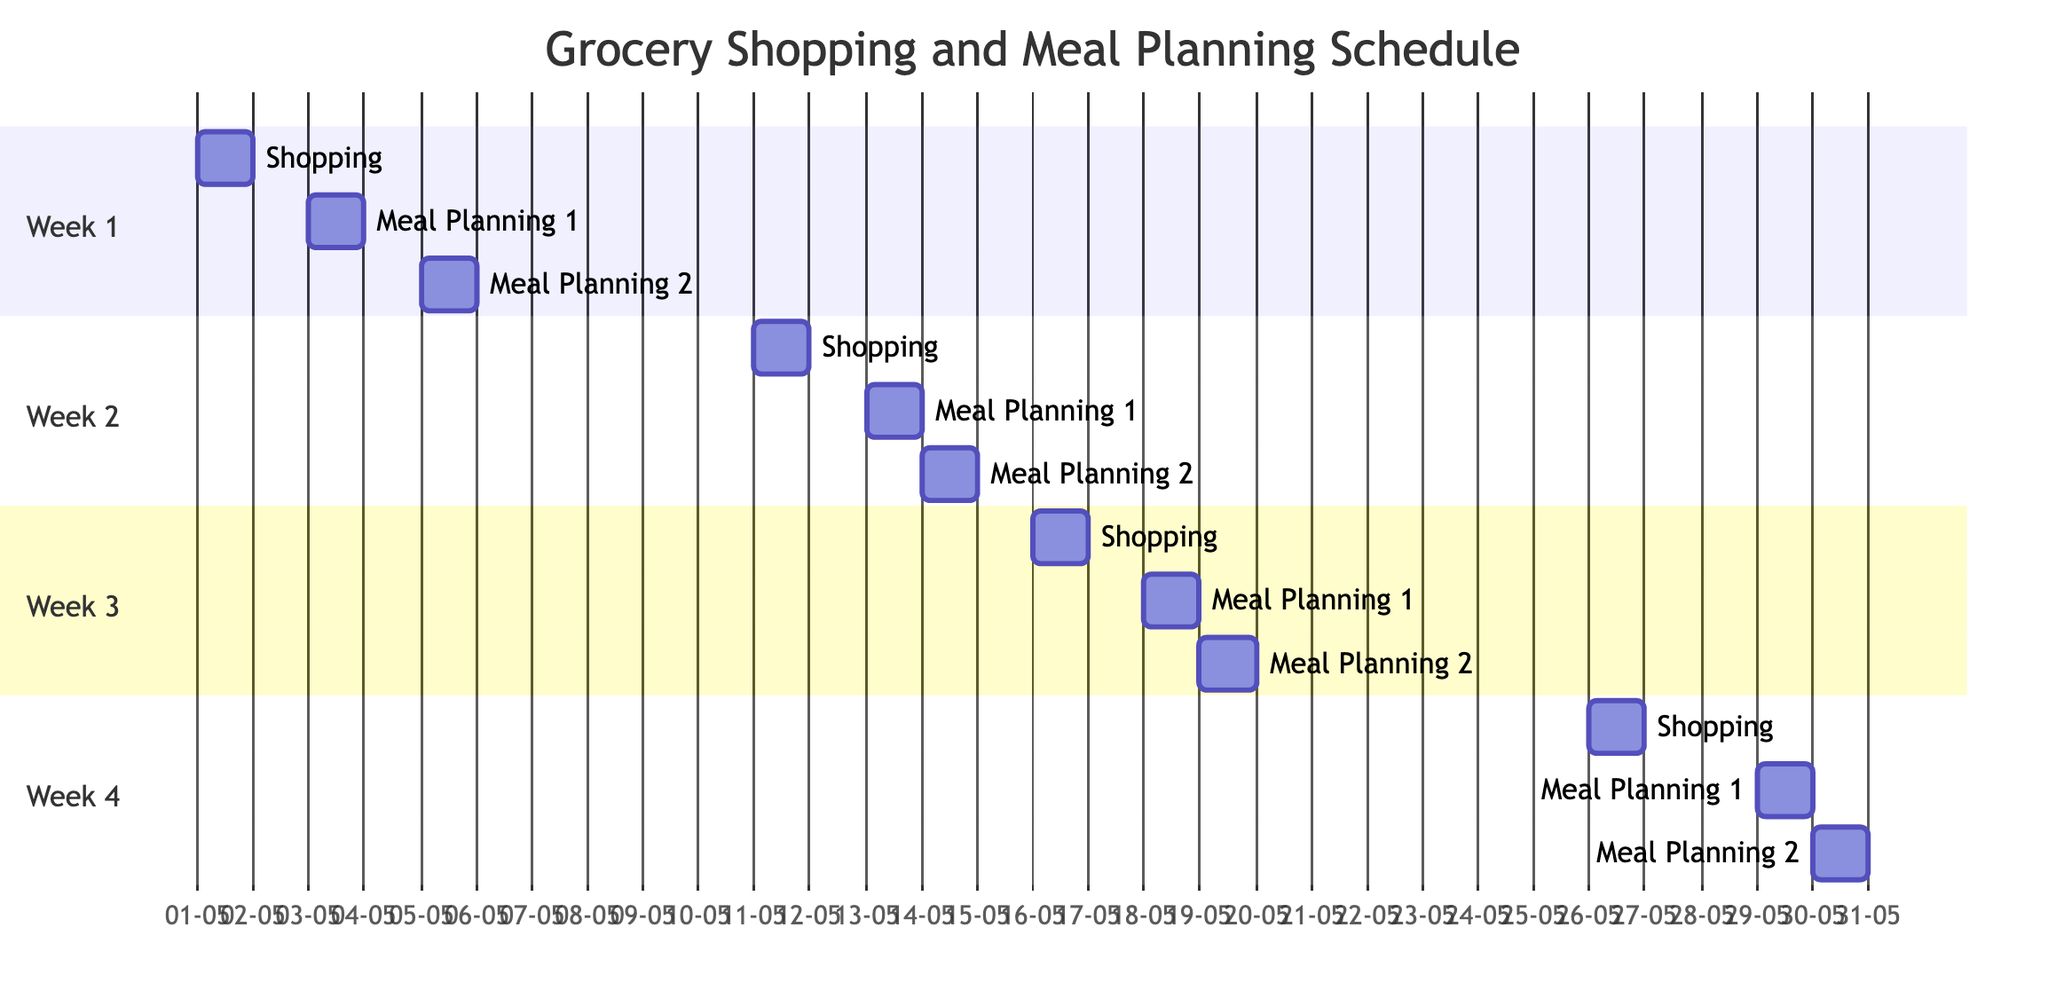What is the shopping day for Week 1? To find the shopping day for Week 1, I look at the section labeled 'Week 1' in the diagram, which states 'Shopping Day: Monday.'
Answer: Monday How many meal planning dates are there in Week 3? In the 'Week 3' section of the diagram, the meal planning dates are listed as 'Thursday' and 'Friday,' which counts as two dates.
Answer: 2 Which items are bought on Week 4 Shopping Day? Referring to the 'Week 4' section, the list of items is mentioned under 'Items,' which includes 'Blueberries, Peaches, Eggplant, Potatoes, Ice Cream, Bread, Pork, Chickpeas.'
Answer: Blueberries, Peaches, Eggplant, Potatoes, Ice Cream, Bread, Pork, Chickpeas What is the first meal planning date in Week 2? Looking in the 'Week 2' section of the diagram, the first meal planning date is noted as 'Saturday,’ which is the first date listed under meal planning.
Answer: Saturday What is the last shopping day in the schedule? I identify the last week in the Gantt chart, which is 'Week 4,' and the shopping day for that week is 'Friday,' indicating it is the last shopping day in the schedule.
Answer: Friday Which week has a shopping day on Tuesday? In the diagram, the 'Week 3' section states the shopping day is 'Tuesday,' thus it is the week with a Tuesday shopping day.
Answer: Week 3 What type of proteins are listed for shopping in Week 2? Under the 'Items' in 'Week 2,' the list categorizes proteins, where 'Beef' and 'Tofu' are specified as the proteins needed; thus, those are the types listed for that week.
Answer: Beef, Tofu How many total weeks are shown in the diagram? By reviewing the sections present in the Gantt chart, there are 'Week 1', 'Week 2', 'Week 3', and 'Week 4,' totaling four weeks in the schedule.
Answer: 4 Which dairy items are included in Week 1 shopping? The 'Week 1' section shows that under 'Dairy', the items listed are 'Milk' and 'Yogurt,' specifying these two items purchased in that week.
Answer: Milk, Yogurt What day of the week is Week 2's shopping? In the diagram's 'Week 2' section, it clearly states that the shopping day is 'Thursday,' pointing to the specific day designated for shopping that week.
Answer: Thursday 